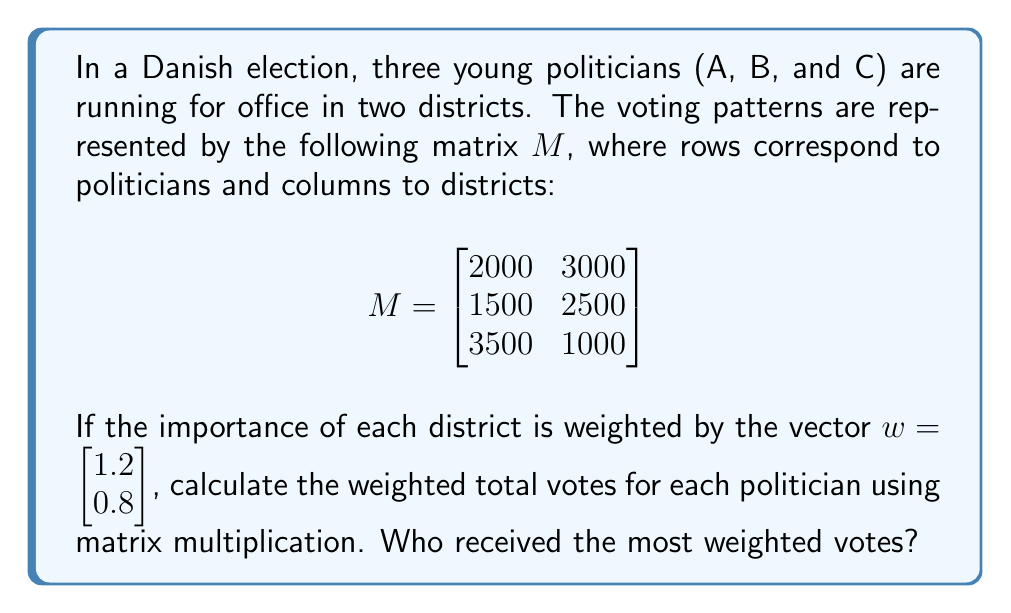Show me your answer to this math problem. To solve this problem, we need to multiply the matrix $M$ by the weight vector $w$. This will give us a new vector representing the weighted total votes for each politician.

Step 1: Set up the matrix multiplication
$$Mw = \begin{bmatrix}
2000 & 3000 \\
1500 & 2500 \\
3500 & 1000
\end{bmatrix} \begin{bmatrix}
1.2 \\
0.8
\end{bmatrix}$$

Step 2: Perform the matrix multiplication
For each row of $M$, multiply by the corresponding element of $w$ and sum:

Politician A: $(2000 \times 1.2) + (3000 \times 0.8) = 2400 + 2400 = 4800$
Politician B: $(1500 \times 1.2) + (2500 \times 0.8) = 1800 + 2000 = 3800$
Politician C: $(3500 \times 1.2) + (1000 \times 0.8) = 4200 + 800 = 5000$

Step 3: Write the result as a vector
$$Mw = \begin{bmatrix}
4800 \\
3800 \\
5000
\end{bmatrix}$$

Step 4: Compare the results
Politician C received the most weighted votes with 5000, followed by Politician A with 4800, and Politician B with 3800.
Answer: Politician C with 5000 weighted votes 